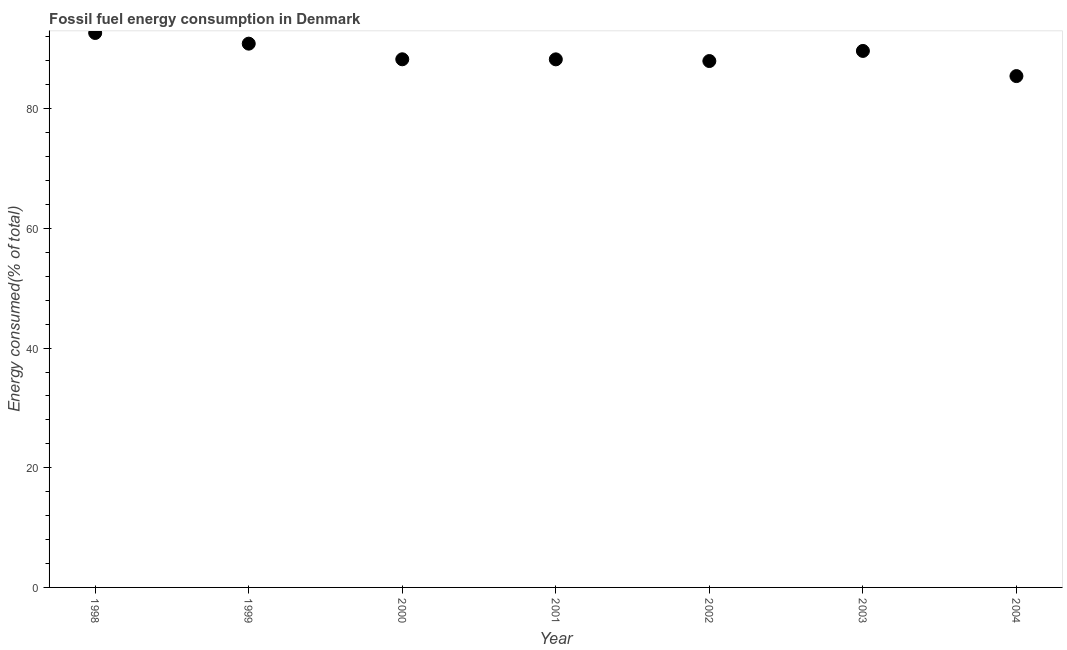What is the fossil fuel energy consumption in 2000?
Offer a terse response. 88.27. Across all years, what is the maximum fossil fuel energy consumption?
Ensure brevity in your answer.  92.67. Across all years, what is the minimum fossil fuel energy consumption?
Make the answer very short. 85.47. What is the sum of the fossil fuel energy consumption?
Keep it short and to the point. 623.21. What is the difference between the fossil fuel energy consumption in 1998 and 2001?
Make the answer very short. 4.41. What is the average fossil fuel energy consumption per year?
Your answer should be compact. 89.03. What is the median fossil fuel energy consumption?
Your answer should be very brief. 88.27. What is the ratio of the fossil fuel energy consumption in 1998 to that in 2000?
Make the answer very short. 1.05. What is the difference between the highest and the second highest fossil fuel energy consumption?
Your answer should be very brief. 1.78. What is the difference between the highest and the lowest fossil fuel energy consumption?
Offer a very short reply. 7.2. How many dotlines are there?
Offer a terse response. 1. Does the graph contain any zero values?
Give a very brief answer. No. What is the title of the graph?
Ensure brevity in your answer.  Fossil fuel energy consumption in Denmark. What is the label or title of the X-axis?
Provide a short and direct response. Year. What is the label or title of the Y-axis?
Provide a short and direct response. Energy consumed(% of total). What is the Energy consumed(% of total) in 1998?
Keep it short and to the point. 92.67. What is the Energy consumed(% of total) in 1999?
Your response must be concise. 90.89. What is the Energy consumed(% of total) in 2000?
Offer a terse response. 88.27. What is the Energy consumed(% of total) in 2001?
Provide a short and direct response. 88.26. What is the Energy consumed(% of total) in 2002?
Offer a terse response. 87.98. What is the Energy consumed(% of total) in 2003?
Your response must be concise. 89.67. What is the Energy consumed(% of total) in 2004?
Keep it short and to the point. 85.47. What is the difference between the Energy consumed(% of total) in 1998 and 1999?
Your answer should be very brief. 1.78. What is the difference between the Energy consumed(% of total) in 1998 and 2000?
Offer a terse response. 4.4. What is the difference between the Energy consumed(% of total) in 1998 and 2001?
Your answer should be compact. 4.41. What is the difference between the Energy consumed(% of total) in 1998 and 2002?
Offer a terse response. 4.69. What is the difference between the Energy consumed(% of total) in 1998 and 2003?
Keep it short and to the point. 3. What is the difference between the Energy consumed(% of total) in 1998 and 2004?
Offer a terse response. 7.2. What is the difference between the Energy consumed(% of total) in 1999 and 2000?
Your answer should be very brief. 2.61. What is the difference between the Energy consumed(% of total) in 1999 and 2001?
Give a very brief answer. 2.62. What is the difference between the Energy consumed(% of total) in 1999 and 2002?
Offer a very short reply. 2.91. What is the difference between the Energy consumed(% of total) in 1999 and 2003?
Provide a succinct answer. 1.22. What is the difference between the Energy consumed(% of total) in 1999 and 2004?
Make the answer very short. 5.42. What is the difference between the Energy consumed(% of total) in 2000 and 2001?
Your answer should be compact. 0.01. What is the difference between the Energy consumed(% of total) in 2000 and 2002?
Give a very brief answer. 0.29. What is the difference between the Energy consumed(% of total) in 2000 and 2003?
Your answer should be compact. -1.4. What is the difference between the Energy consumed(% of total) in 2000 and 2004?
Give a very brief answer. 2.81. What is the difference between the Energy consumed(% of total) in 2001 and 2002?
Keep it short and to the point. 0.28. What is the difference between the Energy consumed(% of total) in 2001 and 2003?
Provide a succinct answer. -1.41. What is the difference between the Energy consumed(% of total) in 2001 and 2004?
Provide a succinct answer. 2.8. What is the difference between the Energy consumed(% of total) in 2002 and 2003?
Your response must be concise. -1.69. What is the difference between the Energy consumed(% of total) in 2002 and 2004?
Keep it short and to the point. 2.51. What is the difference between the Energy consumed(% of total) in 2003 and 2004?
Your answer should be very brief. 4.2. What is the ratio of the Energy consumed(% of total) in 1998 to that in 2001?
Provide a succinct answer. 1.05. What is the ratio of the Energy consumed(% of total) in 1998 to that in 2002?
Your response must be concise. 1.05. What is the ratio of the Energy consumed(% of total) in 1998 to that in 2003?
Provide a short and direct response. 1.03. What is the ratio of the Energy consumed(% of total) in 1998 to that in 2004?
Offer a terse response. 1.08. What is the ratio of the Energy consumed(% of total) in 1999 to that in 2000?
Ensure brevity in your answer.  1.03. What is the ratio of the Energy consumed(% of total) in 1999 to that in 2002?
Provide a short and direct response. 1.03. What is the ratio of the Energy consumed(% of total) in 1999 to that in 2004?
Offer a terse response. 1.06. What is the ratio of the Energy consumed(% of total) in 2000 to that in 2003?
Make the answer very short. 0.98. What is the ratio of the Energy consumed(% of total) in 2000 to that in 2004?
Give a very brief answer. 1.03. What is the ratio of the Energy consumed(% of total) in 2001 to that in 2002?
Provide a succinct answer. 1. What is the ratio of the Energy consumed(% of total) in 2001 to that in 2004?
Give a very brief answer. 1.03. What is the ratio of the Energy consumed(% of total) in 2003 to that in 2004?
Offer a very short reply. 1.05. 